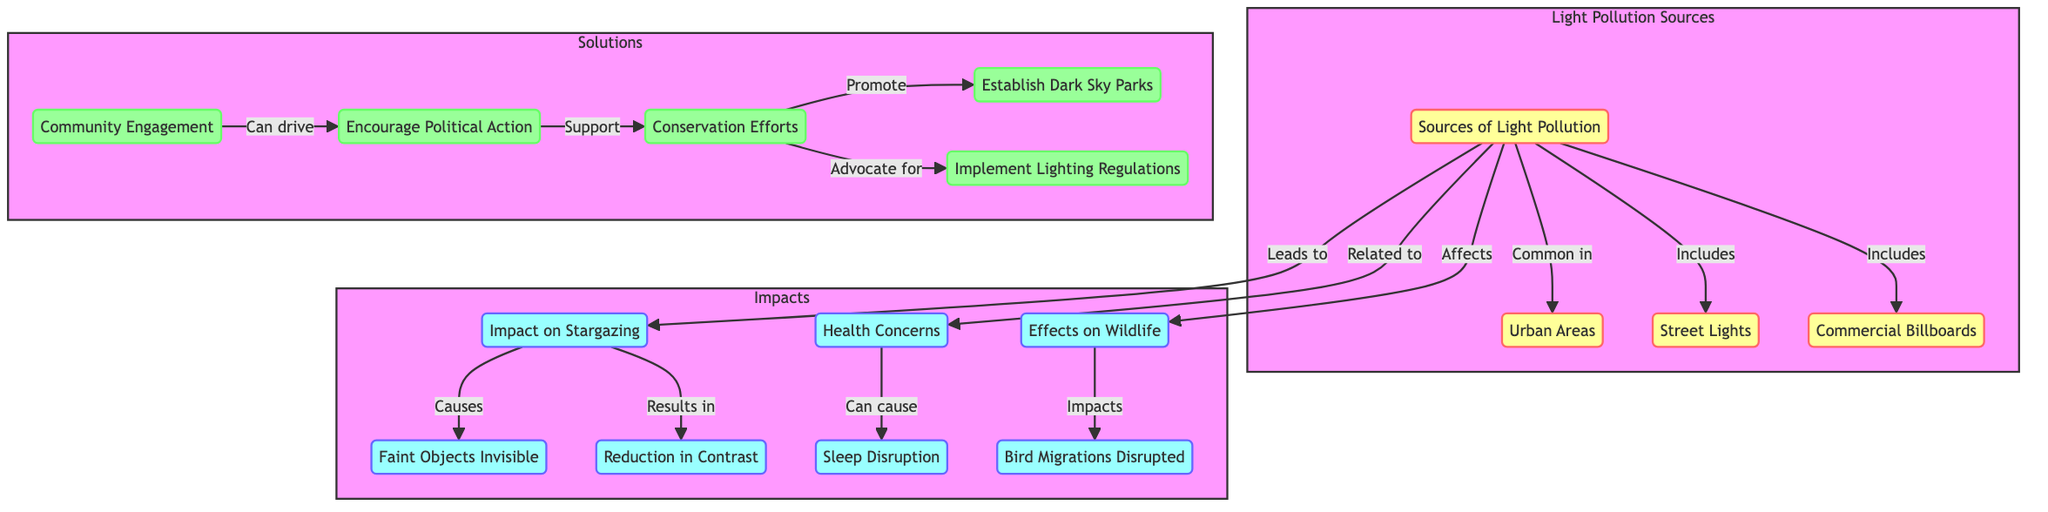What are the sources of light pollution? The diagram identifies "Sources of Light Pollution" as a central node linked to specific types such as "Urban Areas", "Street Lights", and "Commercial Billboards". These are crucial components contributing to light pollution.
Answer: Urban Areas, Street Lights, Commercial Billboards How many health concerns are listed in the diagram? By examining the "Health Concerns" node, we can see that it leads to one direct outcome: "Sleep Disruption". This indicates that there is one primary health concern illustrated in the diagram related to light pollution.
Answer: 1 Which solution promotes dark sky parks? Looking at the "Conservation Efforts" node, it is connected to "Dark Sky Parks", indicating that one of its key functions is to promote these areas to mitigate light pollution.
Answer: Dark Sky Parks What impact does light pollution have on wildlife? The diagram shows a direct connection from "Light Sources" to "Wildlife", which further leads to "Bird Migrations Disrupted", indicating that light pollution adversely affects wildlife.
Answer: Bird Migrations Disrupted What type of action drives community engagement? The diagram illustrates that "Community Engagement" can drive "Political Action". This relationship emphasizes the role of active involvement in politics to address concerns arising from light pollution.
Answer: Political Action How does light pollution affect stargazing? The diagram connects "Light Sources" directly to "Stargazing Impacts", which are then linked to two specific outcomes: "Faint Objects Invisible" and "Reduction in Contrast". This highlights how light pollution diminishes stargazing quality.
Answer: Faint Objects Invisible, Reduction in Contrast What are the protective measures proposed against light pollution? Under the "Solutions" subgraph in the diagram, two main protective measures are identified: "Implement Lighting Regulations" and "Establish Dark Sky Parks". These indicate practical steps to mitigate light pollution's effects.
Answer: Implement Lighting Regulations, Establish Dark Sky Parks What relationship exists between health concerns and sleep disruption? The diagram indicates a flow from "Health Concerns" to "Sleep Disruption", suggesting that light pollution can lead to issues related to health, with sleep disruption being a significant effect.
Answer: Sleep Disruption What type of pollution is addressed in the diagram? The central theme of the diagram revolves around "Light Pollution", as indicated by the main node "Sources of Light Pollution" and its subsequent connections illustrating various impacts and solutions.
Answer: Light Pollution 